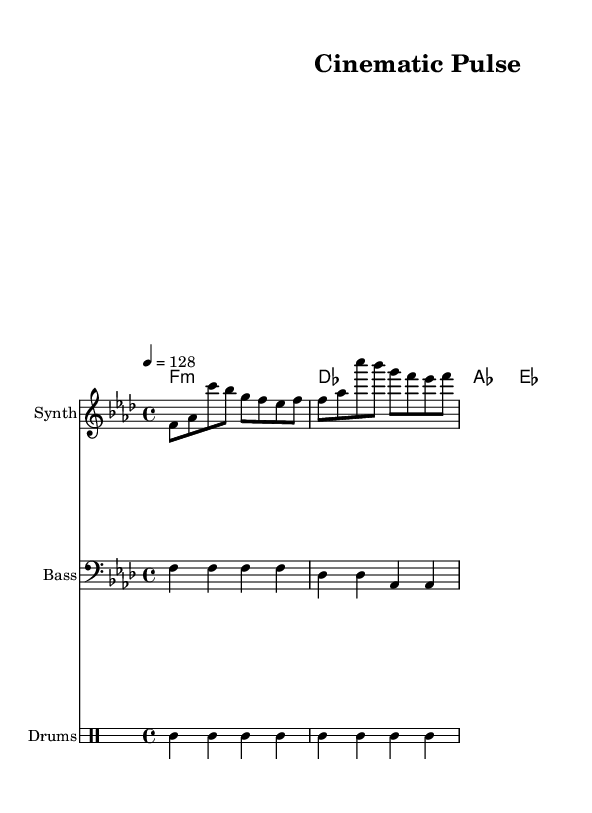What is the key signature of this music? The key signature is indicated with the sharp or flat symbols at the beginning of the staff. Here, there are four flats, which corresponds to F minor.
Answer: F minor What is the time signature of this music? The time signature is shown as a fraction at the beginning of the staff. Here, it is 4 over 4, meaning there are four beats in each measure.
Answer: 4/4 What is the tempo marking of this music? The tempo marking is located at the beginning of the piece, indicating the speed of the music. In this case, it is set to 128 beats per minute.
Answer: 128 How many measures are in the melody section? The melody section contains a series of notes laid out in distinct groups, or measures. By counting these groups, we find there are four measures.
Answer: 4 What type of instrumentation is used in this piece? The types of instruments are indicated in the score, where distinct staffs are labeled for different instruments. This score includes a synthesizer, bass, and drums.
Answer: Synth, Bass, Drums What is the rhythmic pattern for the drum section in one measure? The drum pattern can be identified in the drummode section, showing how the drums are played per beat. Each measure consists of a kick drum followed by a hi-hat and snare drum.
Answer: Kick, Hi-hat, Snare 